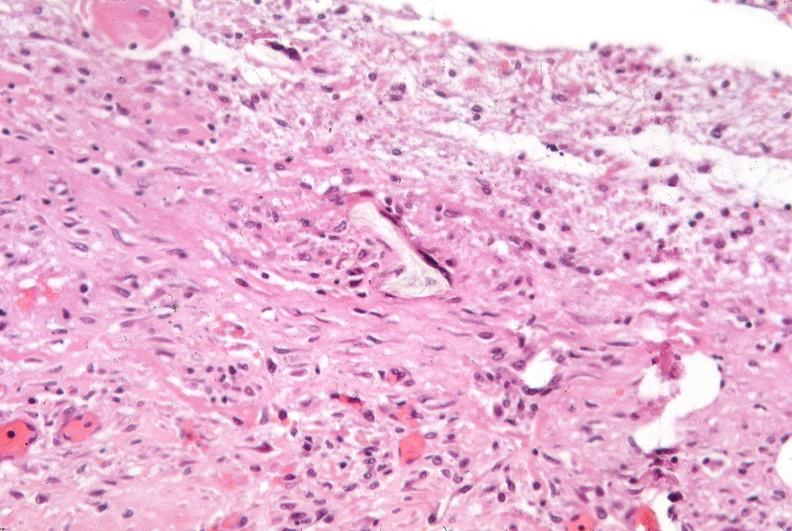does trichrome show pleura, talc reaction?
Answer the question using a single word or phrase. No 